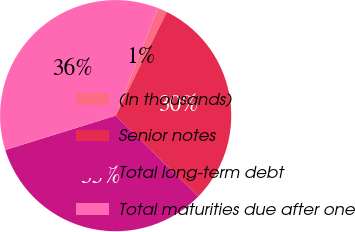Convert chart to OTSL. <chart><loc_0><loc_0><loc_500><loc_500><pie_chart><fcel>(In thousands)<fcel>Senior notes<fcel>Total long-term debt<fcel>Total maturities due after one<nl><fcel>1.35%<fcel>30.02%<fcel>32.88%<fcel>35.75%<nl></chart> 